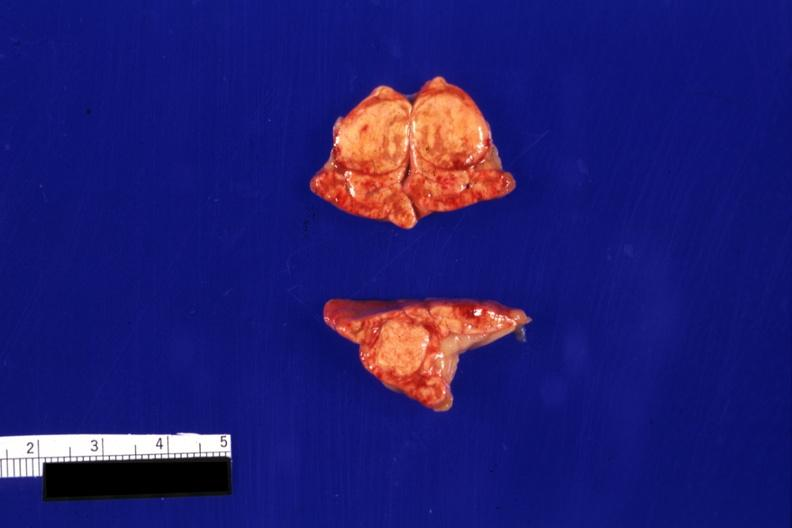s vasculature present?
Answer the question using a single word or phrase. No 